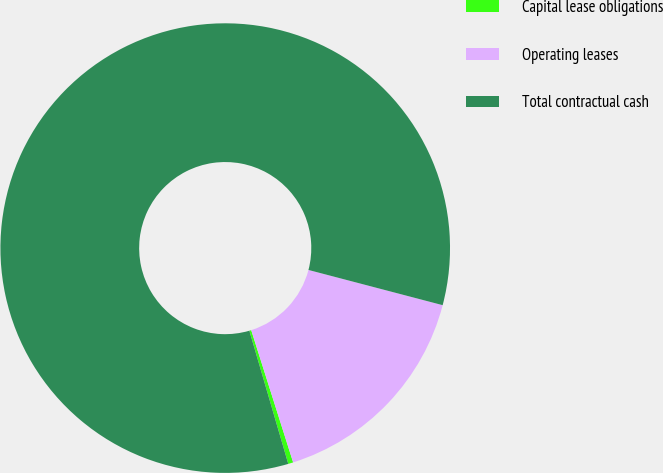Convert chart. <chart><loc_0><loc_0><loc_500><loc_500><pie_chart><fcel>Capital lease obligations<fcel>Operating leases<fcel>Total contractual cash<nl><fcel>0.36%<fcel>16.03%<fcel>83.61%<nl></chart> 